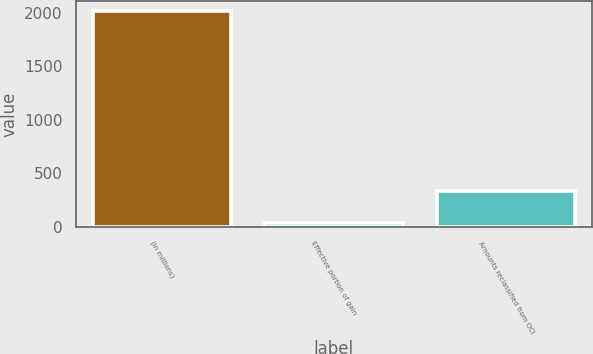Convert chart. <chart><loc_0><loc_0><loc_500><loc_500><bar_chart><fcel>(in millions)<fcel>Effective portion of gain<fcel>Amounts reclassified from OCI<nl><fcel>2012<fcel>42<fcel>335<nl></chart> 